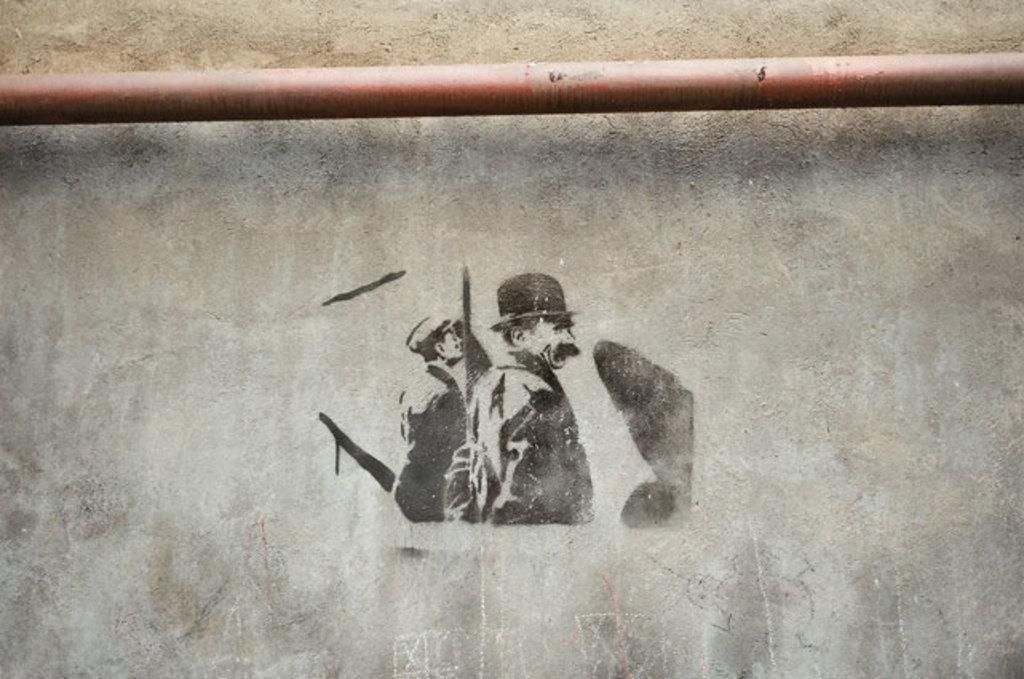What is depicted on the wall in the image? There is a picture of persons on the wall. What object can be seen in the image besides the picture on the wall? There is a rod in the image. What type of punishment is being administered to the persons in the image? There is no indication of punishment in the image; it only shows a picture of persons on the wall and a rod. 